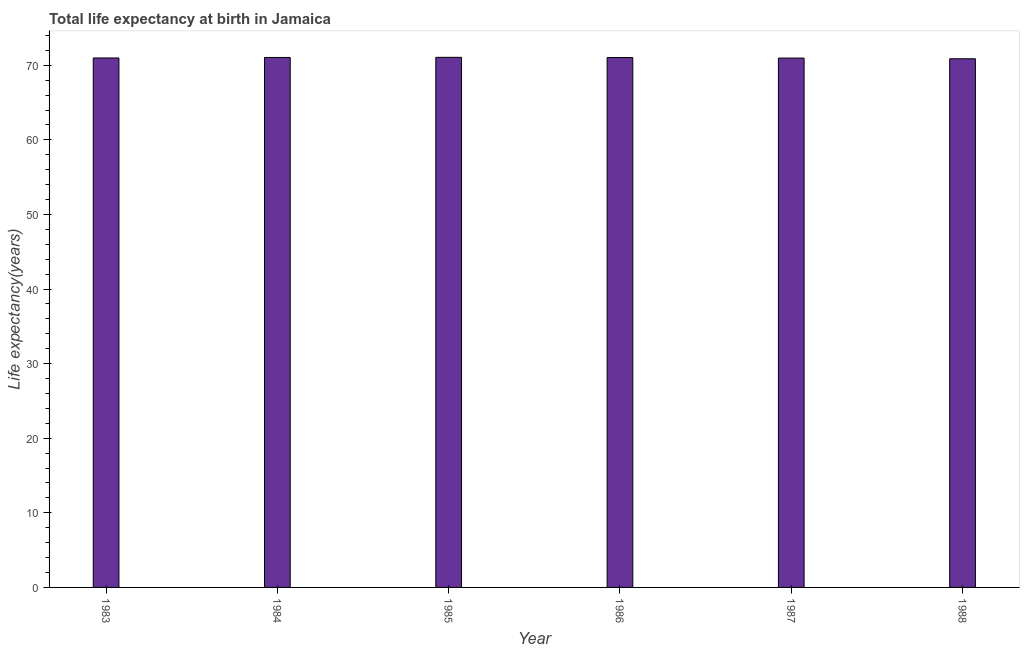Does the graph contain grids?
Give a very brief answer. No. What is the title of the graph?
Keep it short and to the point. Total life expectancy at birth in Jamaica. What is the label or title of the Y-axis?
Keep it short and to the point. Life expectancy(years). What is the life expectancy at birth in 1987?
Your answer should be compact. 70.96. Across all years, what is the maximum life expectancy at birth?
Give a very brief answer. 71.06. Across all years, what is the minimum life expectancy at birth?
Make the answer very short. 70.87. In which year was the life expectancy at birth minimum?
Your response must be concise. 1988. What is the sum of the life expectancy at birth?
Provide a succinct answer. 425.94. What is the difference between the life expectancy at birth in 1986 and 1987?
Offer a very short reply. 0.07. What is the average life expectancy at birth per year?
Your response must be concise. 70.99. What is the median life expectancy at birth?
Offer a terse response. 71. In how many years, is the life expectancy at birth greater than 12 years?
Provide a short and direct response. 6. What is the ratio of the life expectancy at birth in 1983 to that in 1986?
Your answer should be very brief. 1. What is the difference between the highest and the second highest life expectancy at birth?
Provide a short and direct response. 0.02. What is the difference between the highest and the lowest life expectancy at birth?
Make the answer very short. 0.19. In how many years, is the life expectancy at birth greater than the average life expectancy at birth taken over all years?
Make the answer very short. 3. How many bars are there?
Ensure brevity in your answer.  6. What is the difference between two consecutive major ticks on the Y-axis?
Your answer should be compact. 10. Are the values on the major ticks of Y-axis written in scientific E-notation?
Give a very brief answer. No. What is the Life expectancy(years) of 1983?
Offer a very short reply. 70.97. What is the Life expectancy(years) of 1984?
Provide a succinct answer. 71.04. What is the Life expectancy(years) in 1985?
Keep it short and to the point. 71.06. What is the Life expectancy(years) of 1986?
Keep it short and to the point. 71.03. What is the Life expectancy(years) of 1987?
Make the answer very short. 70.96. What is the Life expectancy(years) of 1988?
Your answer should be very brief. 70.87. What is the difference between the Life expectancy(years) in 1983 and 1984?
Provide a succinct answer. -0.07. What is the difference between the Life expectancy(years) in 1983 and 1985?
Your response must be concise. -0.09. What is the difference between the Life expectancy(years) in 1983 and 1986?
Provide a succinct answer. -0.06. What is the difference between the Life expectancy(years) in 1983 and 1987?
Your answer should be compact. 0.01. What is the difference between the Life expectancy(years) in 1983 and 1988?
Make the answer very short. 0.1. What is the difference between the Life expectancy(years) in 1984 and 1985?
Offer a terse response. -0.02. What is the difference between the Life expectancy(years) in 1984 and 1986?
Your response must be concise. 0.01. What is the difference between the Life expectancy(years) in 1984 and 1987?
Your response must be concise. 0.08. What is the difference between the Life expectancy(years) in 1984 and 1988?
Ensure brevity in your answer.  0.17. What is the difference between the Life expectancy(years) in 1985 and 1986?
Your response must be concise. 0.03. What is the difference between the Life expectancy(years) in 1985 and 1987?
Give a very brief answer. 0.1. What is the difference between the Life expectancy(years) in 1985 and 1988?
Provide a succinct answer. 0.19. What is the difference between the Life expectancy(years) in 1986 and 1987?
Make the answer very short. 0.07. What is the difference between the Life expectancy(years) in 1986 and 1988?
Make the answer very short. 0.16. What is the difference between the Life expectancy(years) in 1987 and 1988?
Provide a short and direct response. 0.09. What is the ratio of the Life expectancy(years) in 1983 to that in 1984?
Your answer should be very brief. 1. What is the ratio of the Life expectancy(years) in 1983 to that in 1987?
Make the answer very short. 1. What is the ratio of the Life expectancy(years) in 1983 to that in 1988?
Give a very brief answer. 1. What is the ratio of the Life expectancy(years) in 1984 to that in 1986?
Your answer should be compact. 1. What is the ratio of the Life expectancy(years) in 1984 to that in 1988?
Your response must be concise. 1. What is the ratio of the Life expectancy(years) in 1985 to that in 1987?
Give a very brief answer. 1. What is the ratio of the Life expectancy(years) in 1986 to that in 1988?
Provide a succinct answer. 1. 